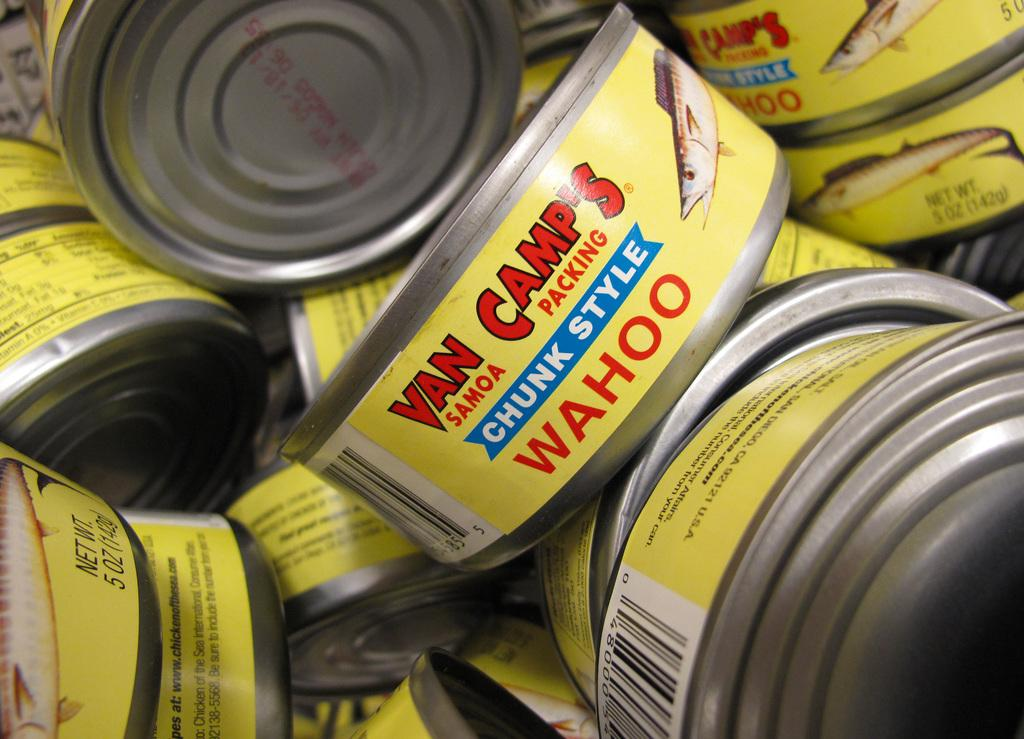<image>
Summarize the visual content of the image. Many cans of Van Camp's chunk style Wahoo. 